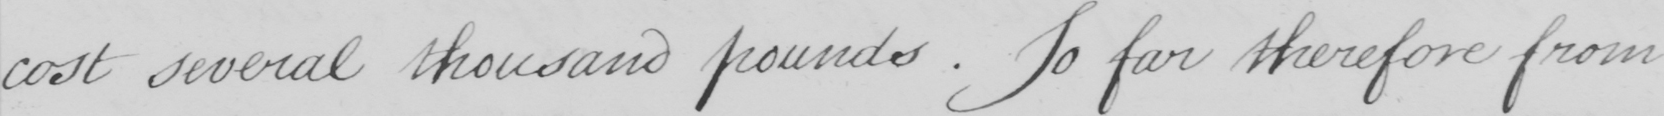What text is written in this handwritten line? cost several thousand pounds . So far therefore from 